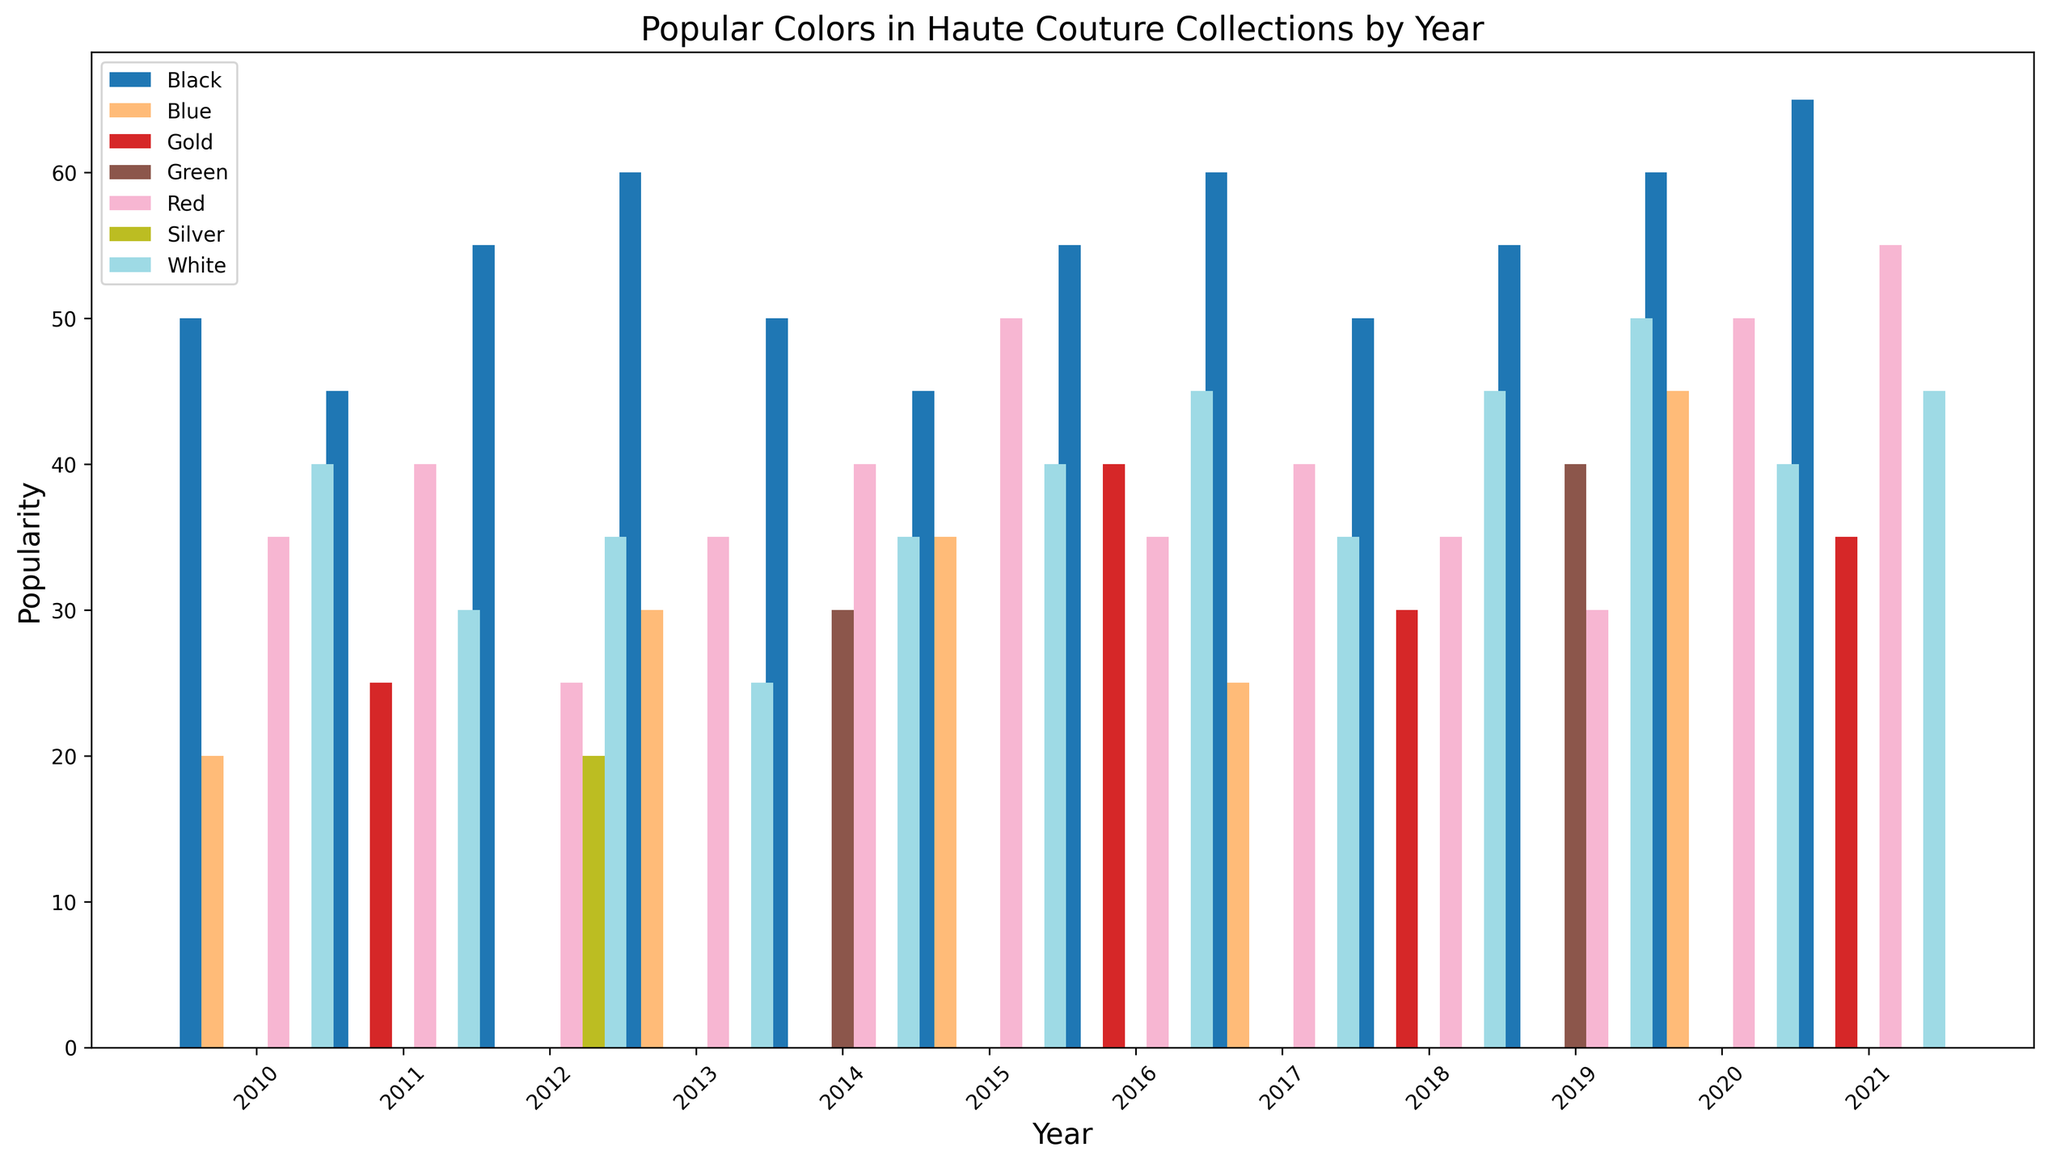What was the most popular color in 2021? To find the most popular color in 2021, look at the bars for 2021 and identify the tallest bar, which corresponds to the color with the highest popularity.
Answer: Black Did any color's popularity stay the same for multiple consecutive years? By examining the heights of the bars for each color across consecutive years, we can see that the popularity bars for black and white change every year.
Answer: No Which year had the lowest popularity of the color blue? Observe the height of the blue bars and identify the shortest blue bar, then note the corresponding year.
Answer: 2017 Which color showed the most significant increase in popularity from 2019 to 2020? To determine this, compare the bar heights for each color in 2019 and 2020 and see which color has the largest difference.
Answer: Blue How did the popularity of red change from 2015 to 2016? Compare the height of the red bars for the years 2015 and 2016. The bar for 2015 (50) is higher than for 2016 (35), indicating a decrease.
Answer: Decreased How many colors were present in the year 2018? Count the number of bars represented in the year 2018. Each bar corresponds to a color.
Answer: 4 What is the combined popularity of white and red in 2020? Locate the bars for white and red in 2020, note their heights (White: 40, Red: 50), and add them together (40 + 50).
Answer: 90 Which color had a steady increase in popularity from 2010 to 2021? Look at the trends of each color from 2010 to 2021, and note any color that consistently shows an upward trend. Black has an increasing trend throughout the years.
Answer: Black Did gold become more or less popular from 2011 to 2021? Compare the height of the gold bars for 2011 (25) and 2021 (35). The bar for 2021 is higher than that of 2011.
Answer: More What was the most significant drop in popularity for any color between two consecutive years? Observe each color for significant changes between consecutive years. The most notable drop is for Red between 2019 (30) and 2020 (50). The decrease is 20 points.
Answer: Red between 2019 and 2020 